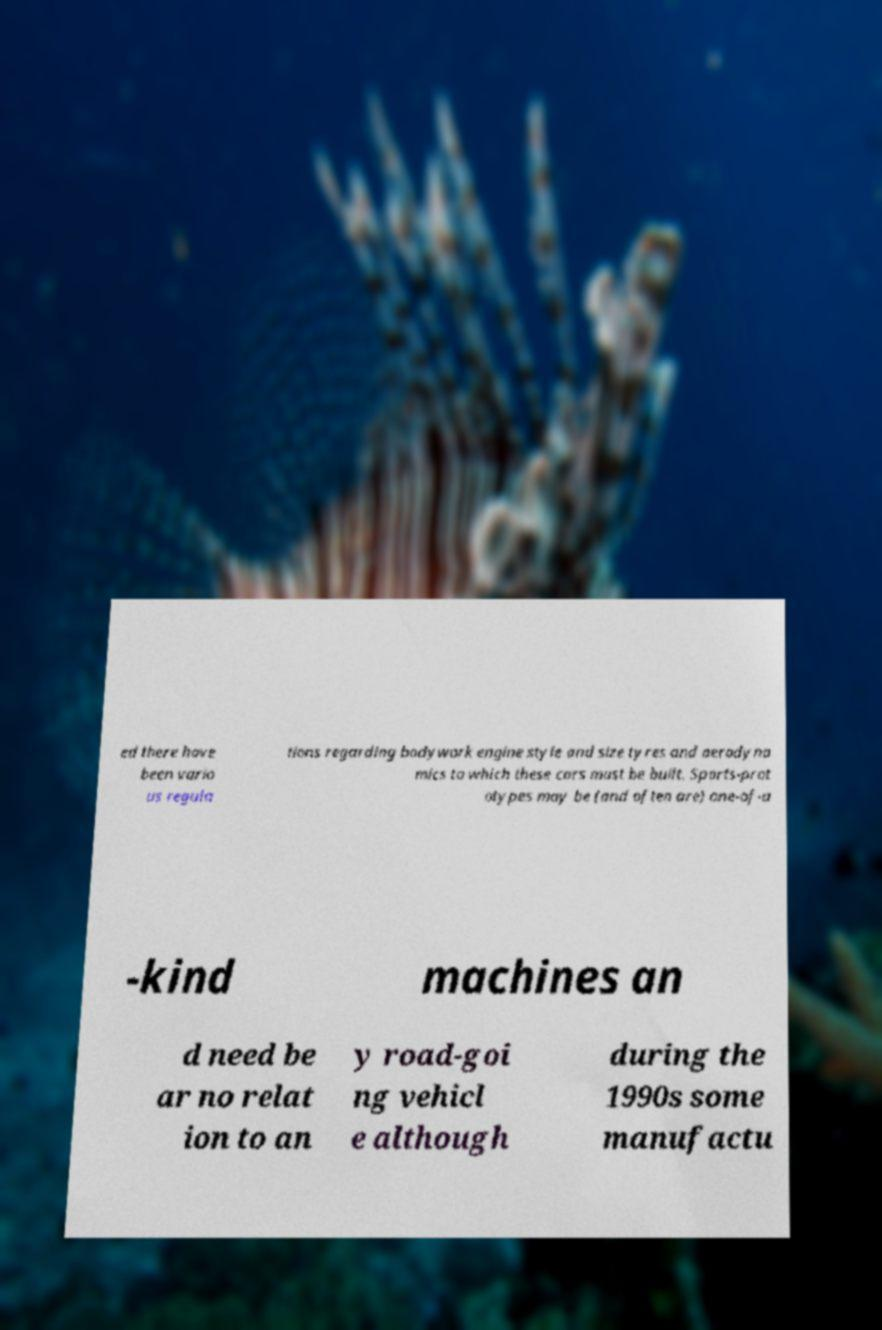Could you assist in decoding the text presented in this image and type it out clearly? ed there have been vario us regula tions regarding bodywork engine style and size tyres and aerodyna mics to which these cars must be built. Sports-prot otypes may be (and often are) one-of-a -kind machines an d need be ar no relat ion to an y road-goi ng vehicl e although during the 1990s some manufactu 